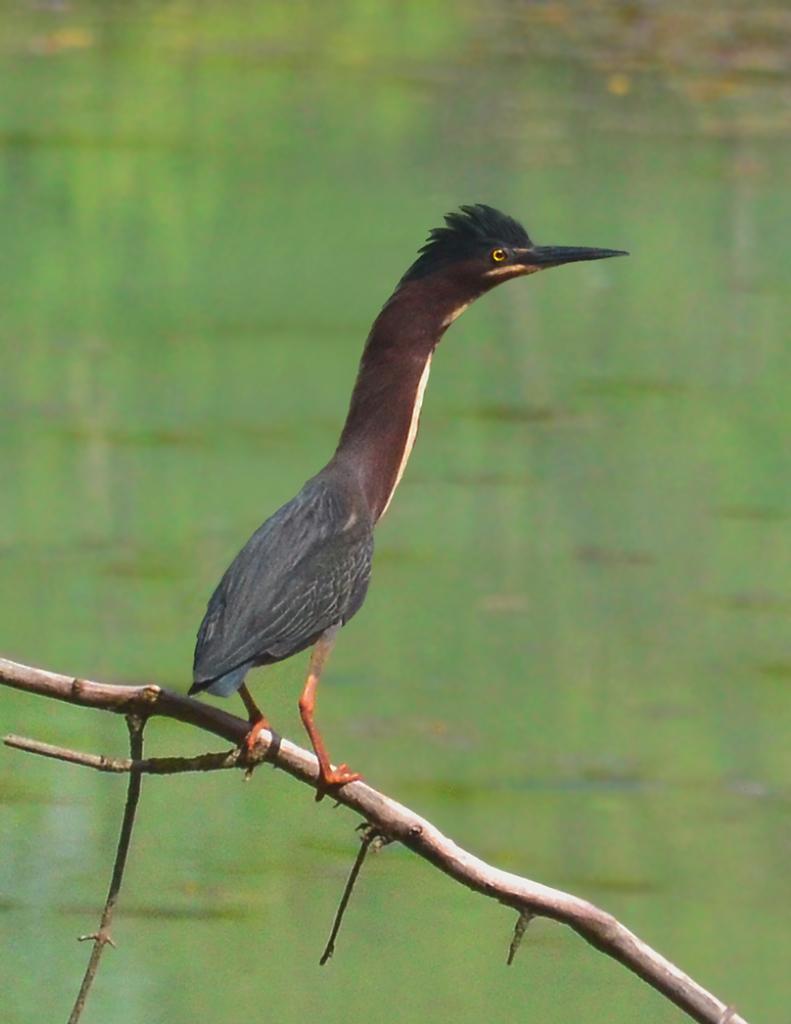Can you describe this image briefly? In this image I can see a bird standing on something. In the background, I can see the water. 